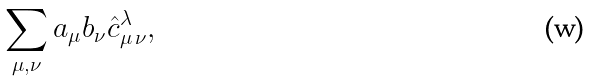Convert formula to latex. <formula><loc_0><loc_0><loc_500><loc_500>\sum _ { \mu , \nu } a _ { \mu } b _ { \nu } \hat { c } ^ { \lambda } _ { \mu \, \nu } ,</formula> 